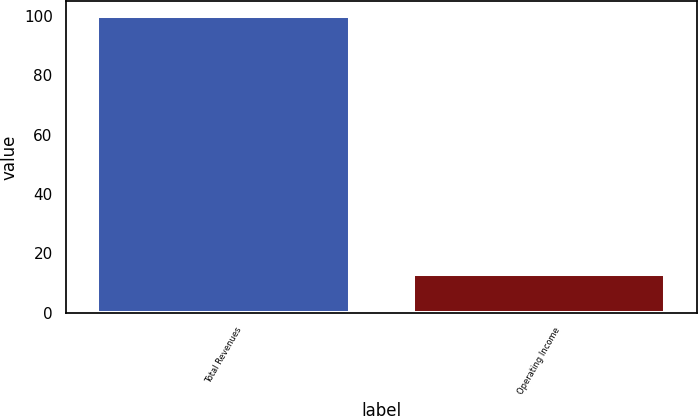Convert chart to OTSL. <chart><loc_0><loc_0><loc_500><loc_500><bar_chart><fcel>Total Revenues<fcel>Operating Income<nl><fcel>100<fcel>13<nl></chart> 